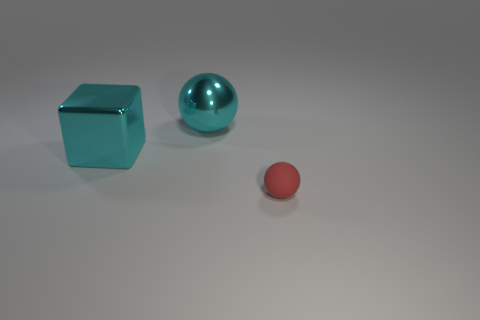Add 2 tiny spheres. How many objects exist? 5 Subtract all balls. How many objects are left? 1 Subtract all cyan balls. How many balls are left? 1 Subtract 2 spheres. How many spheres are left? 0 Add 3 cyan things. How many cyan things are left? 5 Add 1 large cyan rubber cylinders. How many large cyan rubber cylinders exist? 1 Subtract 0 purple cylinders. How many objects are left? 3 Subtract all purple spheres. Subtract all green blocks. How many spheres are left? 2 Subtract all green blocks. How many yellow balls are left? 0 Subtract all cyan things. Subtract all large balls. How many objects are left? 0 